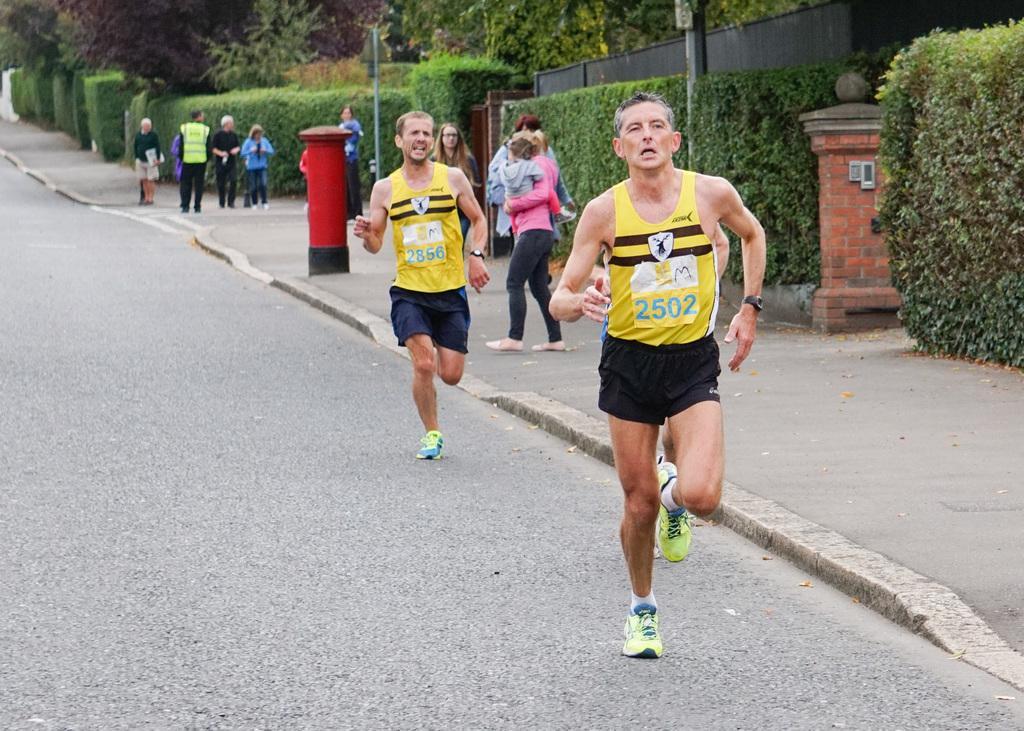Describe this image in one or two sentences. In this picture we can see two people running on the road and in the background we can see a group of people, poles, plants, trees, wall, post box and some objects. 